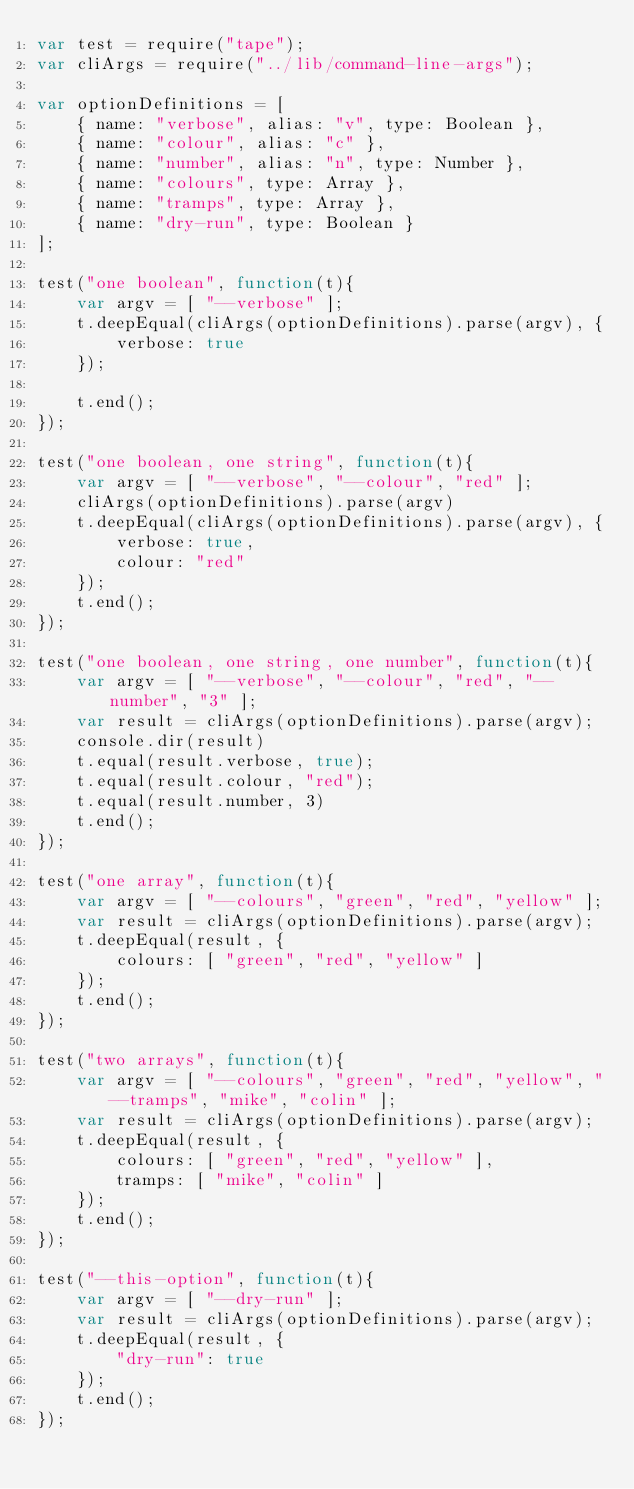<code> <loc_0><loc_0><loc_500><loc_500><_JavaScript_>var test = require("tape");
var cliArgs = require("../lib/command-line-args");

var optionDefinitions = [
    { name: "verbose", alias: "v", type: Boolean },
    { name: "colour", alias: "c" },
    { name: "number", alias: "n", type: Number },
    { name: "colours", type: Array },
    { name: "tramps", type: Array },
    { name: "dry-run", type: Boolean }
];

test("one boolean", function(t){
    var argv = [ "--verbose" ];
    t.deepEqual(cliArgs(optionDefinitions).parse(argv), {
        verbose: true
    });
    
    t.end();
});

test("one boolean, one string", function(t){
    var argv = [ "--verbose", "--colour", "red" ];
    cliArgs(optionDefinitions).parse(argv)
    t.deepEqual(cliArgs(optionDefinitions).parse(argv), {
        verbose: true,
        colour: "red"
    });
    t.end();
});

test("one boolean, one string, one number", function(t){
    var argv = [ "--verbose", "--colour", "red", "--number", "3" ];
    var result = cliArgs(optionDefinitions).parse(argv);
    console.dir(result)
    t.equal(result.verbose, true);
    t.equal(result.colour, "red");
    t.equal(result.number, 3)
    t.end();
});

test("one array", function(t){
    var argv = [ "--colours", "green", "red", "yellow" ];
    var result = cliArgs(optionDefinitions).parse(argv);
    t.deepEqual(result, {
        colours: [ "green", "red", "yellow" ]
    });
    t.end();
});

test("two arrays", function(t){
    var argv = [ "--colours", "green", "red", "yellow", "--tramps", "mike", "colin" ];
    var result = cliArgs(optionDefinitions).parse(argv);
    t.deepEqual(result, {
        colours: [ "green", "red", "yellow" ],
        tramps: [ "mike", "colin" ]
    });
    t.end();
});

test("--this-option", function(t){
    var argv = [ "--dry-run" ];
    var result = cliArgs(optionDefinitions).parse(argv);
    t.deepEqual(result, {
        "dry-run": true
    });
    t.end();
});
</code> 